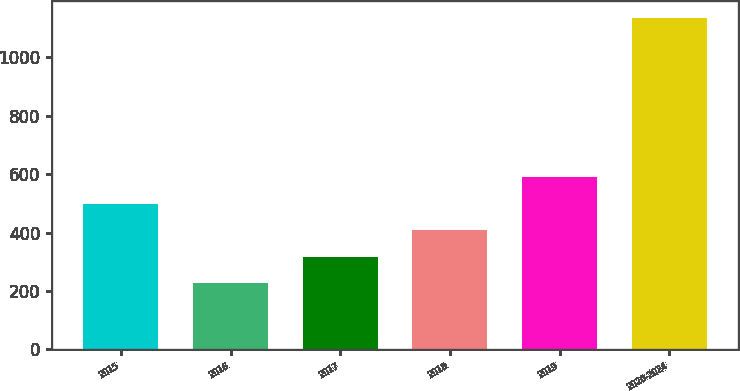Convert chart. <chart><loc_0><loc_0><loc_500><loc_500><bar_chart><fcel>2015<fcel>2016<fcel>2017<fcel>2018<fcel>2019<fcel>2020-2024<nl><fcel>499.1<fcel>227<fcel>317.7<fcel>408.4<fcel>589.8<fcel>1134<nl></chart> 